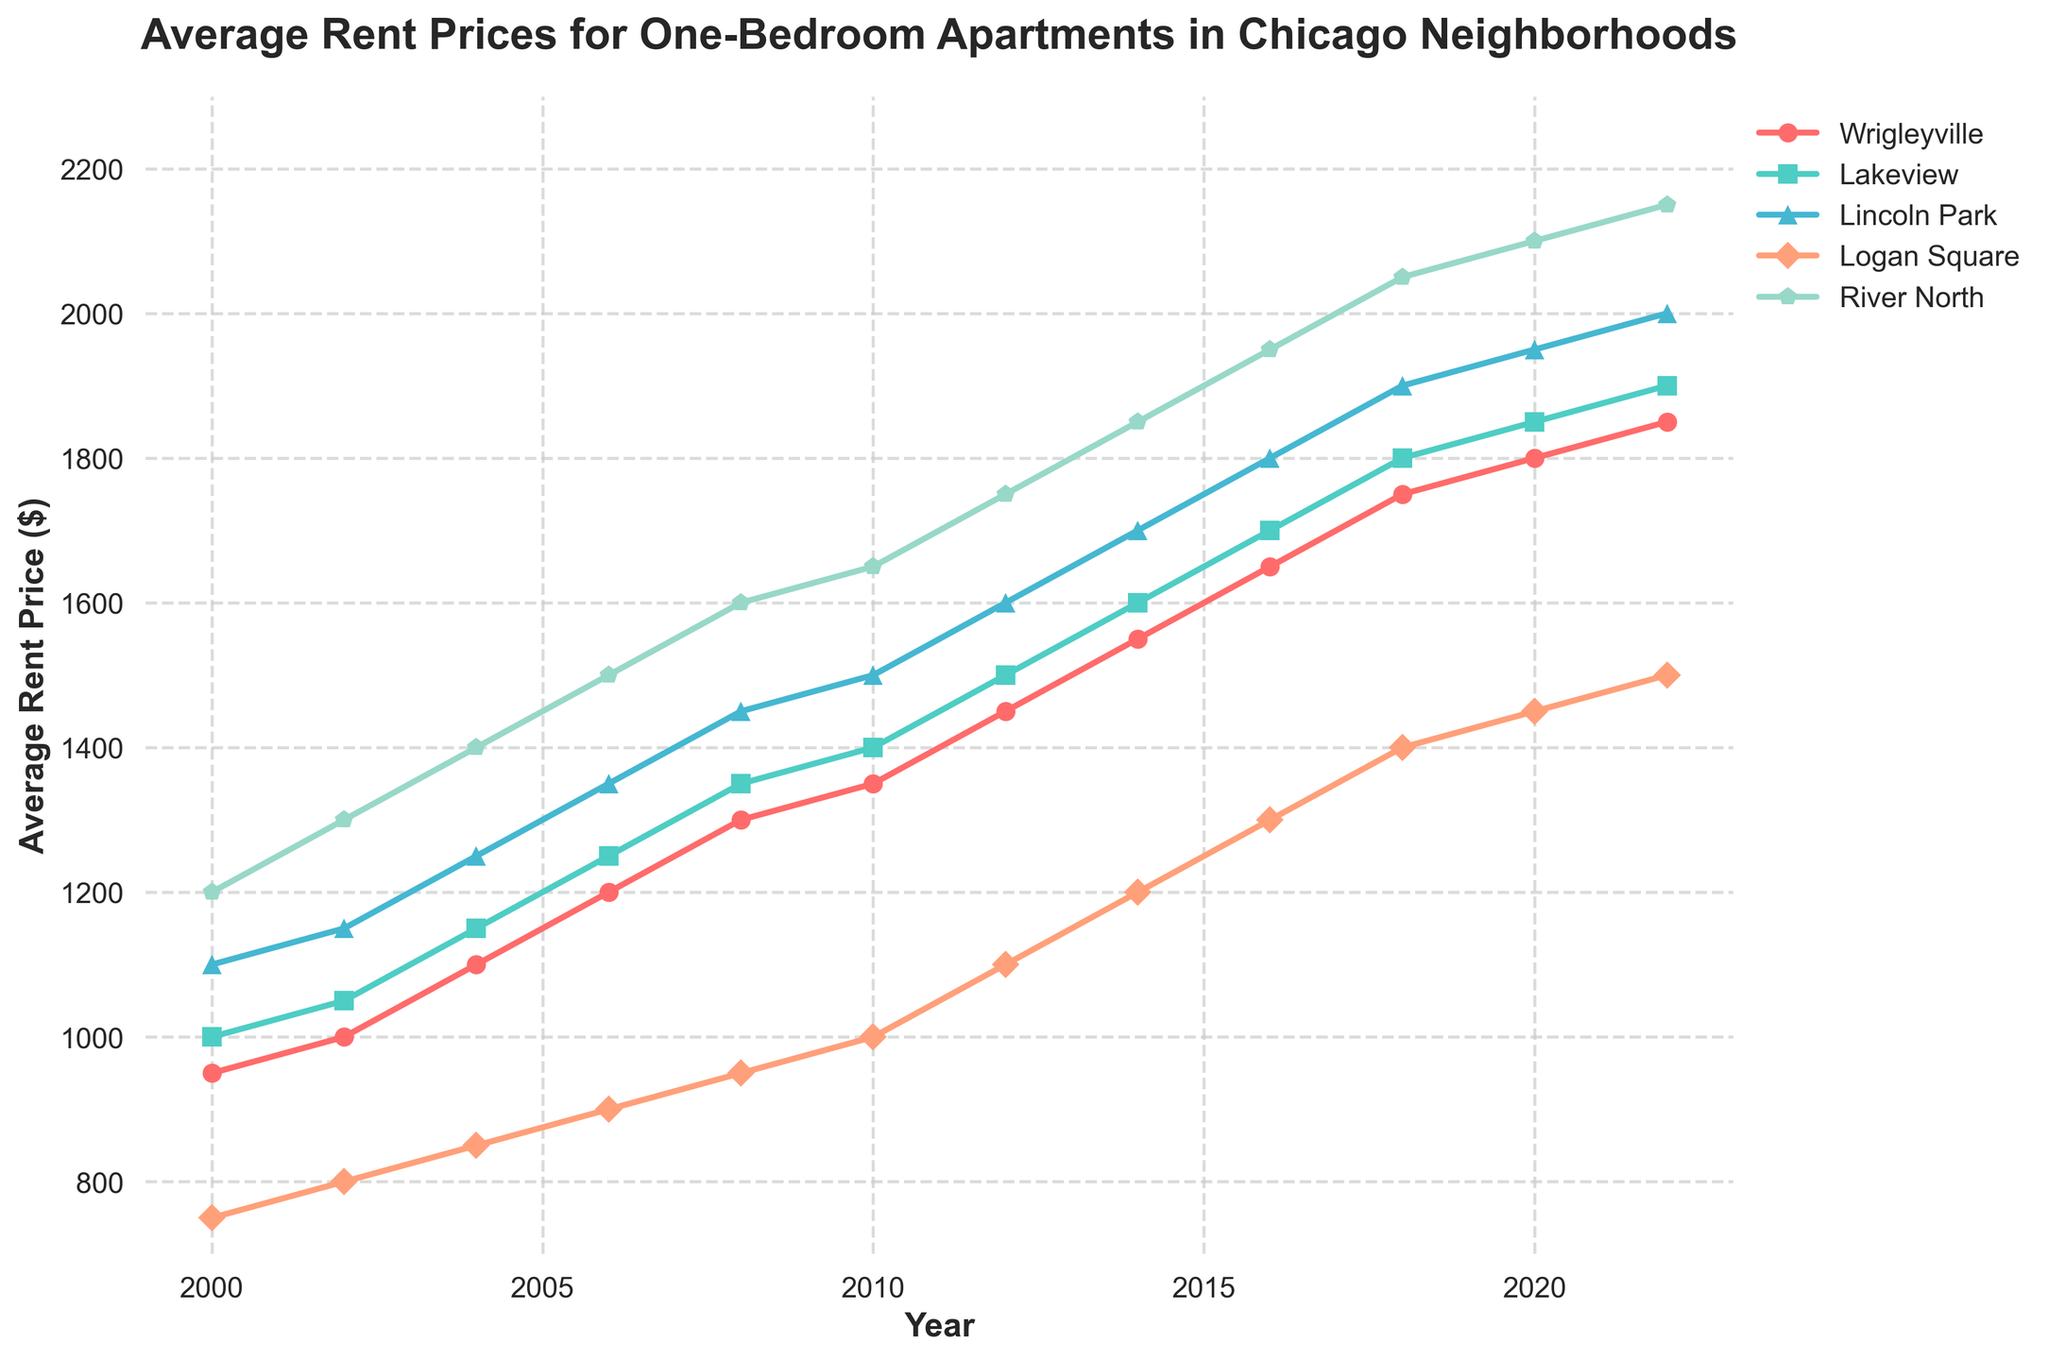What was the average rent price in Wrigleyville in 2000 compared to 2022? To find the difference in rent prices between 2000 and 2022 in Wrigleyville, look at the corresponding data points on the line chart for both years. Wrigleyville's rent in 2000 was $950, and in 2022 it was $1850. Subtract 950 from 1850 to find the difference.
Answer: $900 Between Lakeview and Lincoln Park, which neighborhood had higher rent prices on average over the years displayed? To determine which neighborhood had higher average rent prices, look visually at the line chart trends for Lakeview and Lincoln Park. The Lincoln Park rent line consistently trends higher than Lakeview for the majority of the years displayed, indicating Lincoln Park had higher rents on average.
Answer: Lincoln Park During which period did Logan Square see the biggest jump in rent prices? By scanning the Logan Square line on the chart, you can visually observe the biggest increase. Notice that between 2012 and 2014, Logan Square rent increased from $1100 to $1200, indicating the steepest ascent.
Answer: 2012-2014 What is the minimum and maximum rent price reported for River North? To find the minimum and maximum rent prices for River North, look at the lowest and highest points on the River North line on the chart. The minimum rent price is $1200 (in 2000), and the maximum is $2150 (in 2022).
Answer: $1200, $2150 By how much did the average rent in Wrigleyville increase from 2010 to 2020? Locate the rent prices for Wrigleyville in 2010 and 2020. In 2010, rent was $1350. In 2020, it was $1800. Subtract 1350 from 1800 to get the increase.
Answer: $450 Which neighborhood had the lowest rent increase from 2000 to 2022? To determine the neighborhood with the lowest increase, calculate the difference in rent from 2000 to 2022 for each neighborhood. Compare these differences: Wrigleyville ($1850-$950), Lakeview ($1900-$1000), Lincoln Park ($2000-$1100), Logan Square ($1500-$750), River North ($2150-$1200). Logan Square shows the smallest increase of $750.
Answer: Logan Square In what year did Lakeview's rent prices become higher than Wrigleyville's? By analyzing the convergence and divergence of the Lakeview and Wrigleyville lines, Lakeview's rent prices remain higher than Wrigleyville from 2000 through all years shown. Therefore, there is no single year where Lakeview's rents first became higher.
Answer: Never How do the rent trend slopes for Wrigleyville and River North compare? Visually examine the slopes of Wrigleyville and River North lines. Both lines show an increasing trend but River North's slope is steeper throughout the years on the x-axis, indicating a more rapid increase in rents for River North compared to Wrigleyville.
Answer: River North steeper 